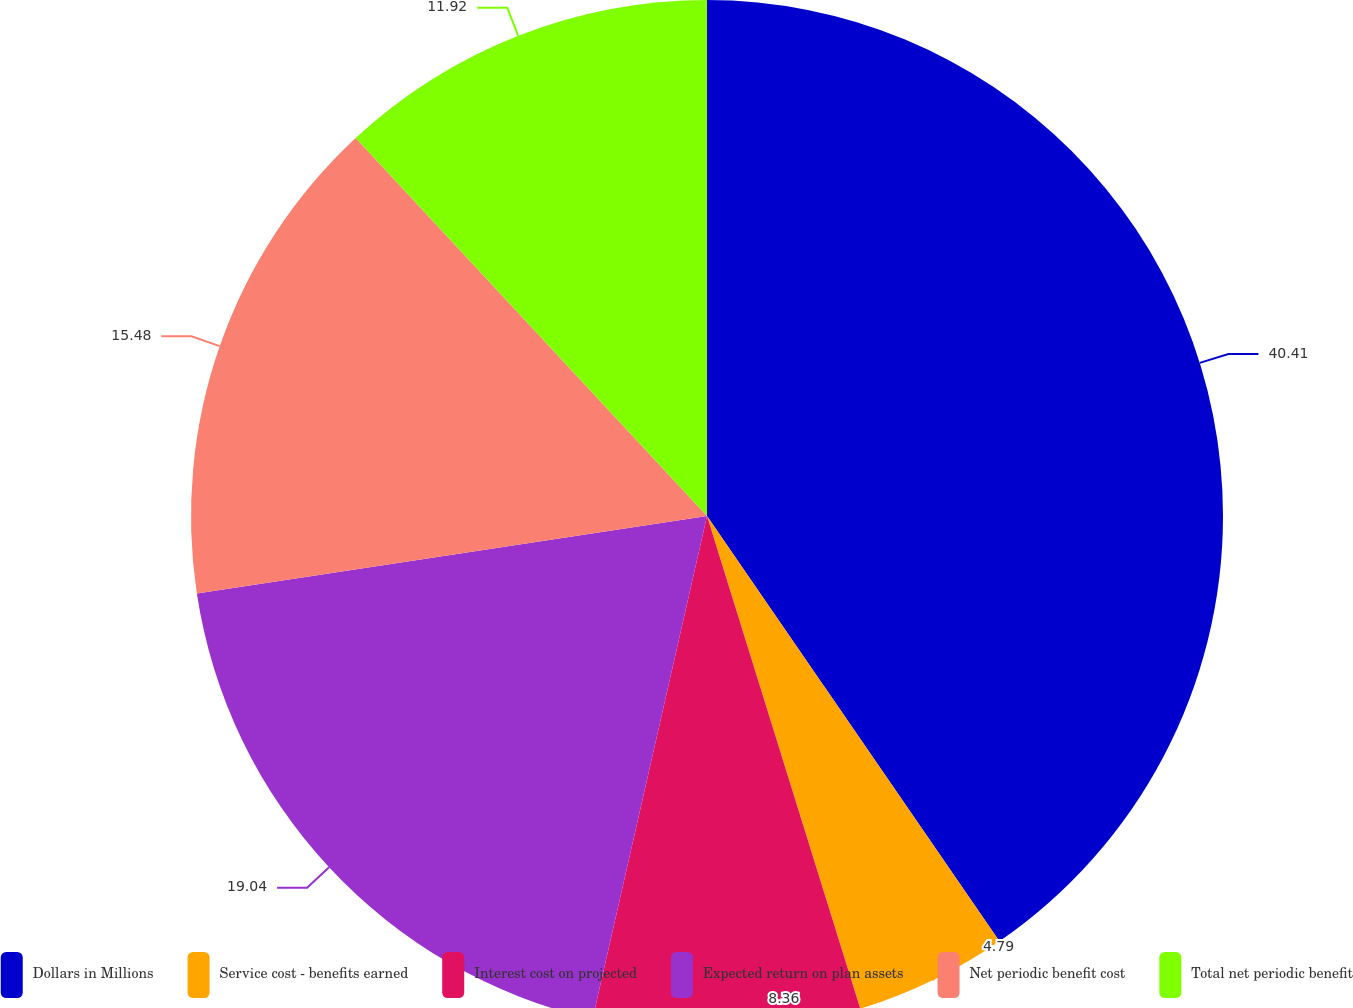Convert chart to OTSL. <chart><loc_0><loc_0><loc_500><loc_500><pie_chart><fcel>Dollars in Millions<fcel>Service cost - benefits earned<fcel>Interest cost on projected<fcel>Expected return on plan assets<fcel>Net periodic benefit cost<fcel>Total net periodic benefit<nl><fcel>40.41%<fcel>4.79%<fcel>8.36%<fcel>19.04%<fcel>15.48%<fcel>11.92%<nl></chart> 